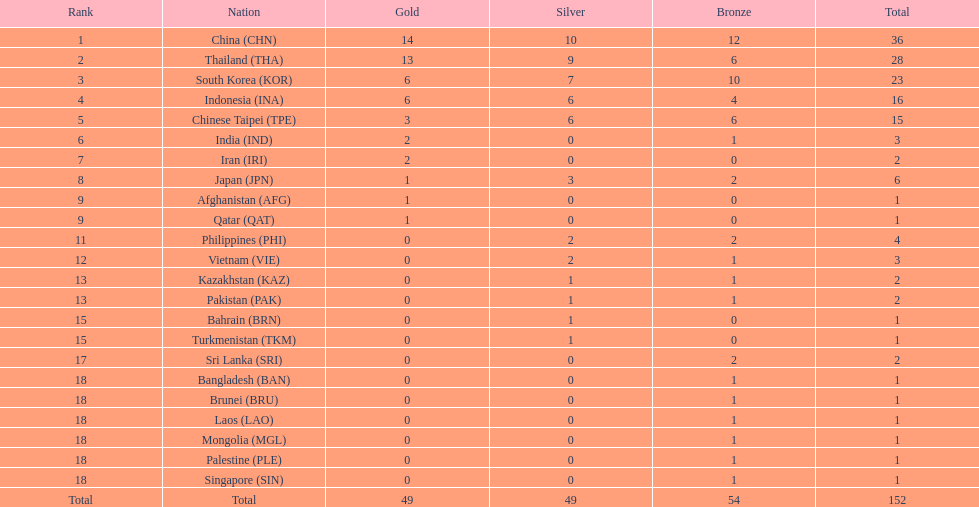Which nation finished first in total medals earned? China (CHN). 